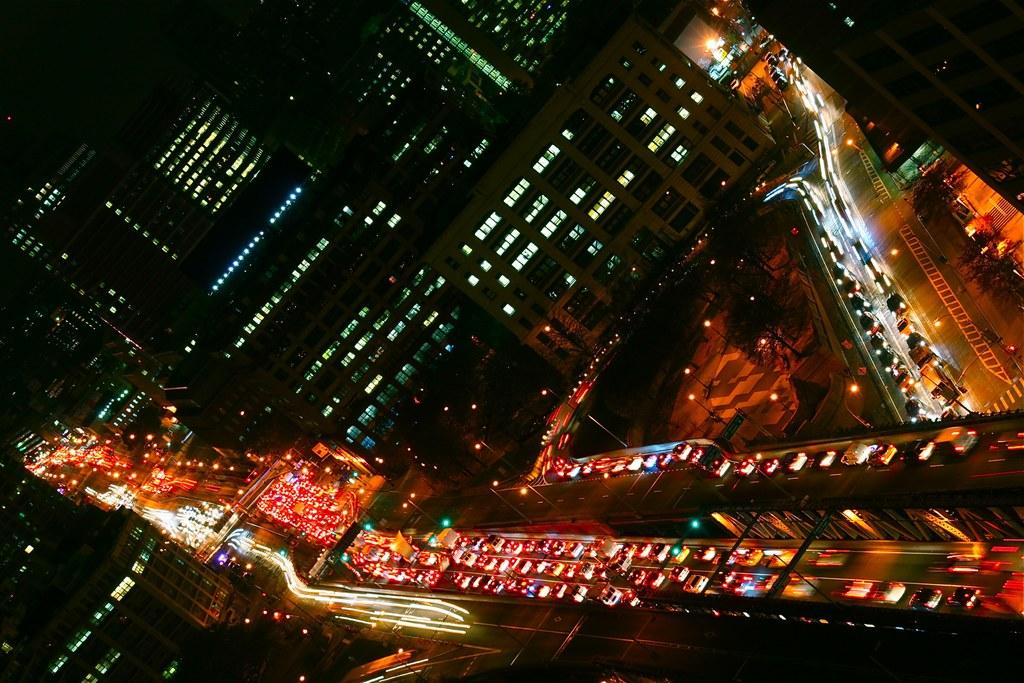What type of structures are present in the image? There are buildings in the image. What type of transportation infrastructure is visible in the image? There are roads in the image. What type of vehicles can be seen on the roads in the image? There are vehicles on the roads in the image. What is the judge doing in the aftermath of the birthday party in the image? There is no judge, birthday party, or aftermath present in the image. What type of cake is being served at the birthday party in the image? There is no birthday party present in the image. 